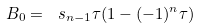Convert formula to latex. <formula><loc_0><loc_0><loc_500><loc_500>B _ { 0 } = \ s _ { n - 1 } \tau ( 1 - ( - 1 ) ^ { n } \tau )</formula> 